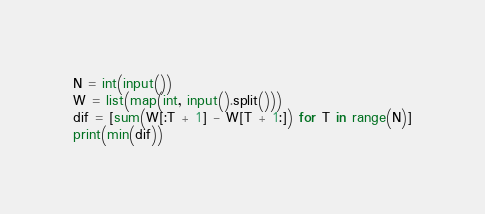<code> <loc_0><loc_0><loc_500><loc_500><_Python_>N = int(input())
W = list(map(int, input().split()))
dif = [sum(W[:T + 1] - W[T + 1:]) for T in range(N)]
print(min(dif))</code> 